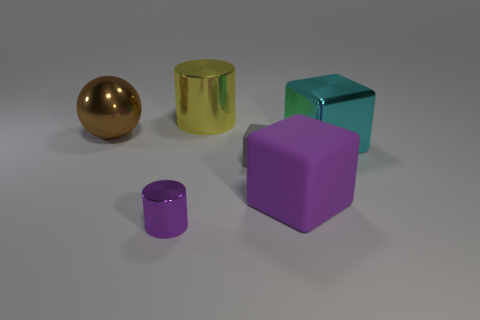There is a small cylinder that is the same color as the large matte block; what is its material?
Give a very brief answer. Metal. What is the cylinder in front of the large cube on the right side of the purple cube made of?
Your answer should be compact. Metal. Is the metal block the same size as the yellow metal thing?
Ensure brevity in your answer.  Yes. How many things are either matte objects right of the tiny gray block or objects behind the purple metallic cylinder?
Make the answer very short. 5. Is the number of metal things that are in front of the tiny rubber block greater than the number of large cyan cylinders?
Give a very brief answer. Yes. How many other things are the same shape as the big purple object?
Ensure brevity in your answer.  2. There is a large object that is on the right side of the big brown ball and behind the big cyan block; what is its material?
Your answer should be very brief. Metal. How many objects are either yellow things or gray matte objects?
Your response must be concise. 2. Are there more large blocks than brown objects?
Offer a very short reply. Yes. There is a metallic cylinder that is behind the metal thing on the left side of the tiny shiny object; what size is it?
Offer a very short reply. Large. 